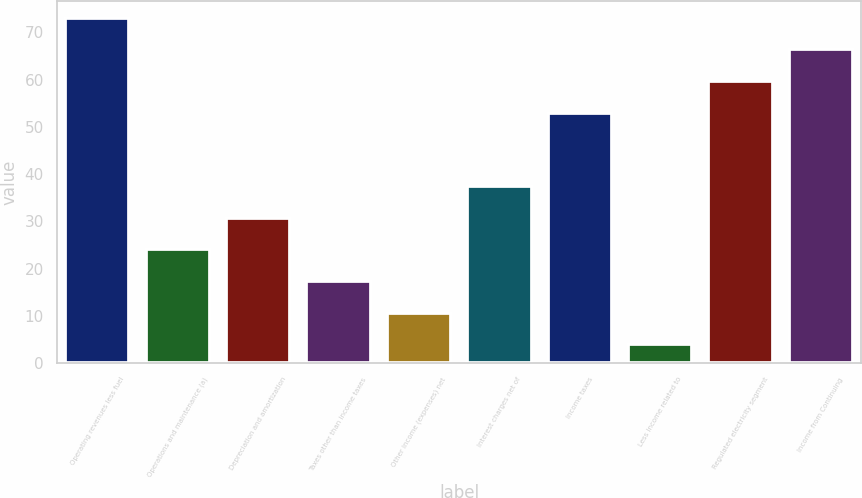Convert chart. <chart><loc_0><loc_0><loc_500><loc_500><bar_chart><fcel>Operating revenues less fuel<fcel>Operations and maintenance (a)<fcel>Depreciation and amortization<fcel>Taxes other than income taxes<fcel>Other income (expenses) net<fcel>Interest charges net of<fcel>Income taxes<fcel>Less income related to<fcel>Regulated electricity segment<fcel>Income from Continuing<nl><fcel>73.1<fcel>24.1<fcel>30.8<fcel>17.4<fcel>10.7<fcel>37.5<fcel>53<fcel>4<fcel>59.7<fcel>66.4<nl></chart> 